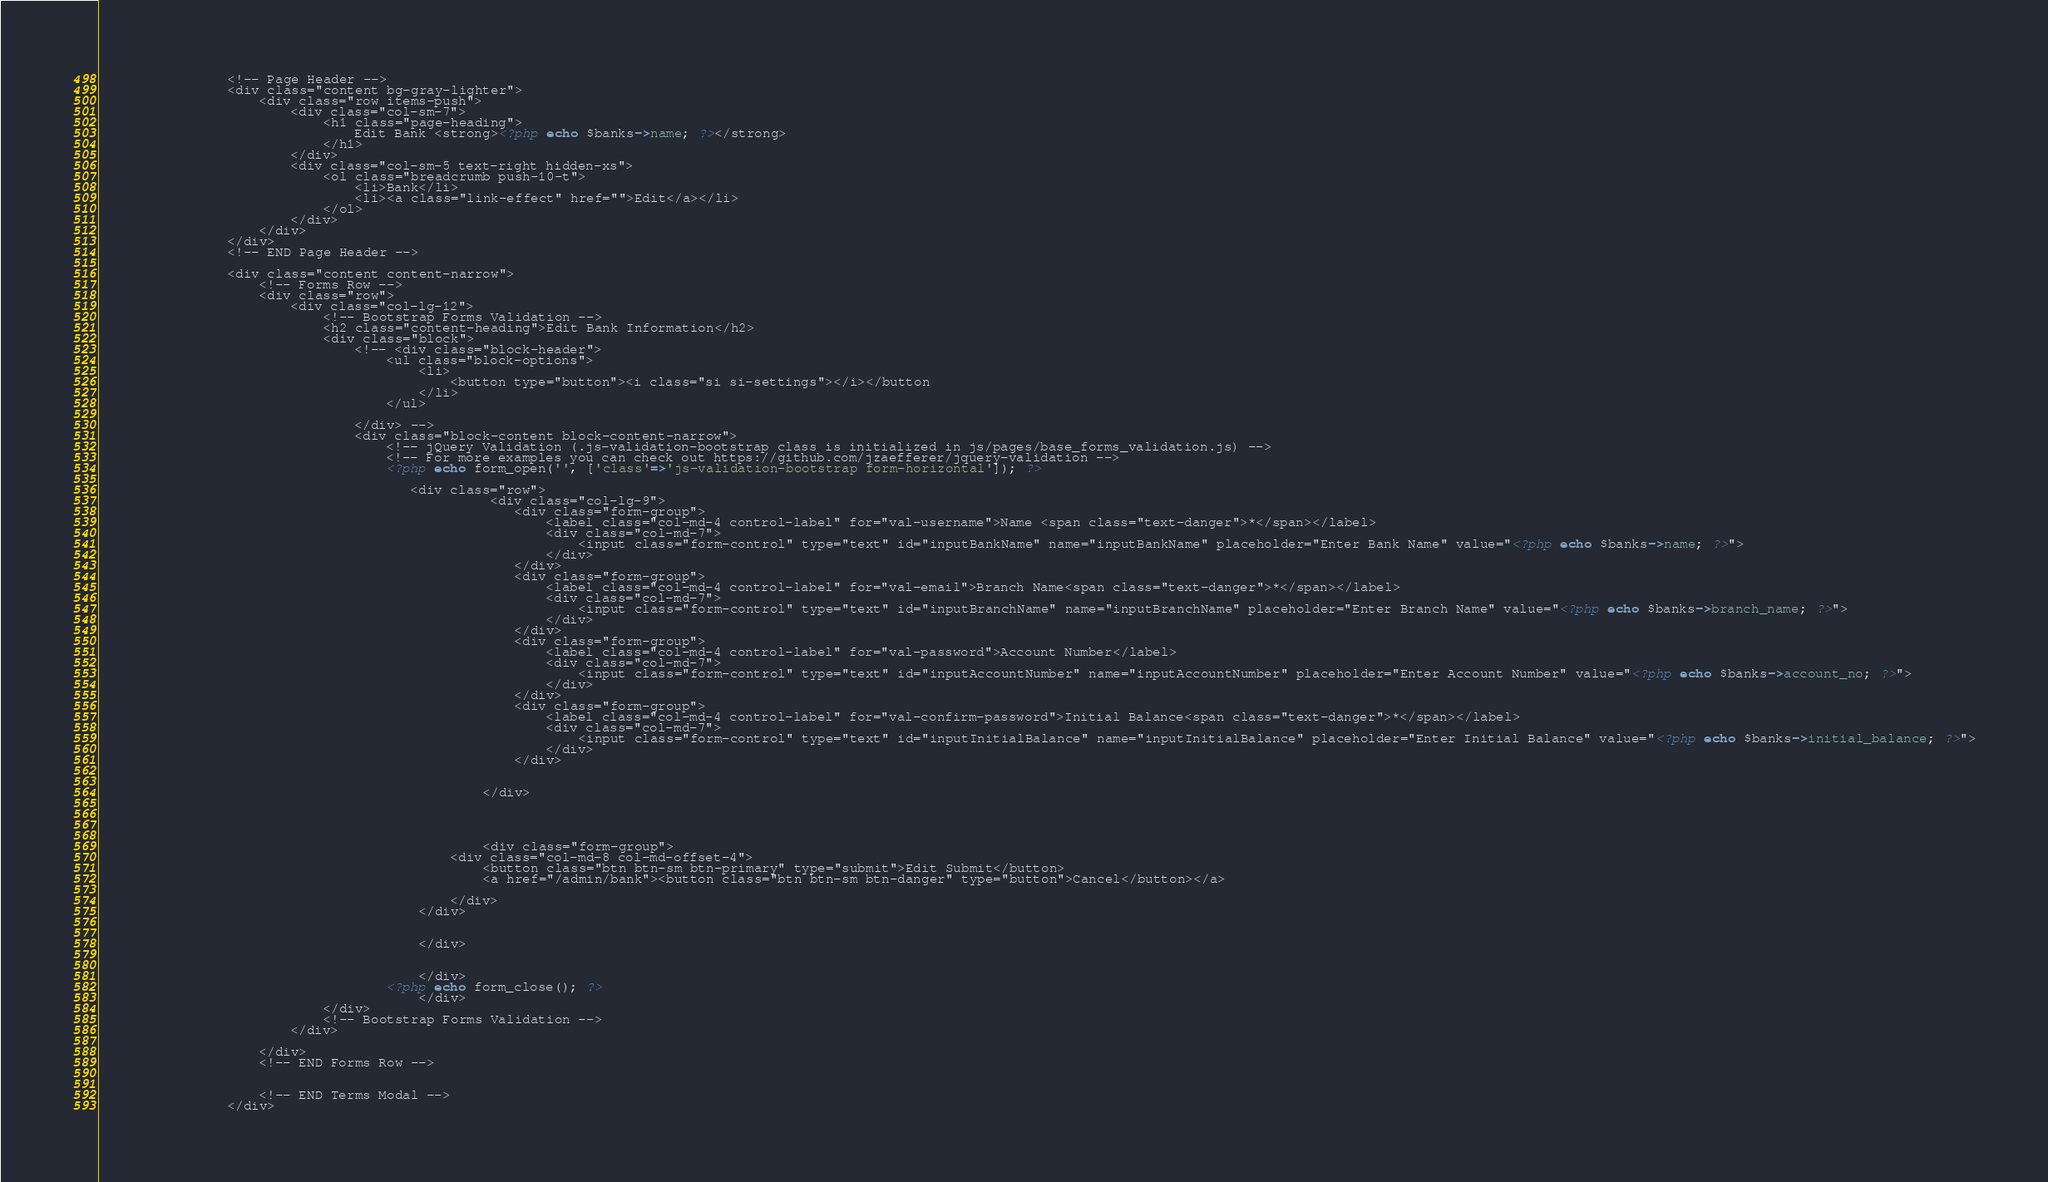Convert code to text. <code><loc_0><loc_0><loc_500><loc_500><_PHP_>                <!-- Page Header -->
                <div class="content bg-gray-lighter">
                    <div class="row items-push">
                        <div class="col-sm-7">
                            <h1 class="page-heading">
                                Edit Bank <strong><?php echo $banks->name; ?></strong>
                            </h1>
                        </div>
                        <div class="col-sm-5 text-right hidden-xs">
                            <ol class="breadcrumb push-10-t">
                                <li>Bank</li>
                                <li><a class="link-effect" href="">Edit</a></li>
                            </ol>
                        </div>
                    </div>
                </div>
                <!-- END Page Header -->

                <div class="content content-narrow">
                    <!-- Forms Row -->
                    <div class="row">
                        <div class="col-lg-12">
                            <!-- Bootstrap Forms Validation -->
                            <h2 class="content-heading">Edit Bank Information</h2>
                            <div class="block">
                                <!-- <div class="block-header">
                                    <ul class="block-options">
                                        <li>
                                            <button type="button"><i class="si si-settings"></i></button
                                        </li>
                                    </ul>
                                    
                                </div> -->
                                <div class="block-content block-content-narrow">
                                    <!-- jQuery Validation (.js-validation-bootstrap class is initialized in js/pages/base_forms_validation.js) -->
                                    <!-- For more examples you can check out https://github.com/jzaefferer/jquery-validation -->
                                    <?php echo form_open('', ['class'=>'js-validation-bootstrap form-horizontal']); ?>
                                    
                                       <div class="row">
                                                 <div class="col-lg-9">
                                                    <div class="form-group">
                                                        <label class="col-md-4 control-label" for="val-username">Name <span class="text-danger">*</span></label>
                                                        <div class="col-md-7">
                                                            <input class="form-control" type="text" id="inputBankName" name="inputBankName" placeholder="Enter Bank Name" value="<?php echo $banks->name; ?>">
                                                        </div>
                                                    </div>   
                                                    <div class="form-group">
                                                        <label class="col-md-4 control-label" for="val-email">Branch Name<span class="text-danger">*</span></label>
                                                        <div class="col-md-7">
                                                            <input class="form-control" type="text" id="inputBranchName" name="inputBranchName" placeholder="Enter Branch Name" value="<?php echo $banks->branch_name; ?>">
                                                        </div>
                                                    </div>
                                                    <div class="form-group">
                                                        <label class="col-md-4 control-label" for="val-password">Account Number</label>
                                                        <div class="col-md-7">
                                                            <input class="form-control" type="text" id="inputAccountNumber" name="inputAccountNumber" placeholder="Enter Account Number" value="<?php echo $banks->account_no; ?>">
                                                        </div>
                                                    </div>
                                                    <div class="form-group">
                                                        <label class="col-md-4 control-label" for="val-confirm-password">Initial Balance<span class="text-danger">*</span></label>
                                                        <div class="col-md-7">
                                                            <input class="form-control" type="text" id="inputInitialBalance" name="inputInitialBalance" placeholder="Enter Initial Balance" value="<?php echo $banks->initial_balance; ?>">
                                                        </div>
                                                    </div>
                                                    

                                                </div>
                                                
                                                    
                                                   
                                                
                                                <div class="form-group">
                                            <div class="col-md-8 col-md-offset-4">
                                                <button class="btn btn-sm btn-primary" type="submit">Edit Submit</button>
                                                <a href="/admin/bank"><button class="btn btn-sm btn-danger" type="button">Cancel</button></a>

                                            </div>
                                        </div>  
                                            
                                        
                                        </div>
                                                                        
                                        
                                        </div>
                                    <?php echo form_close(); ?>
                                        </div>
                            </div>
                            <!-- Bootstrap Forms Validation -->
                        </div>
                        
                    </div>
                    <!-- END Forms Row -->

                    
                    <!-- END Terms Modal -->
                </div></code> 